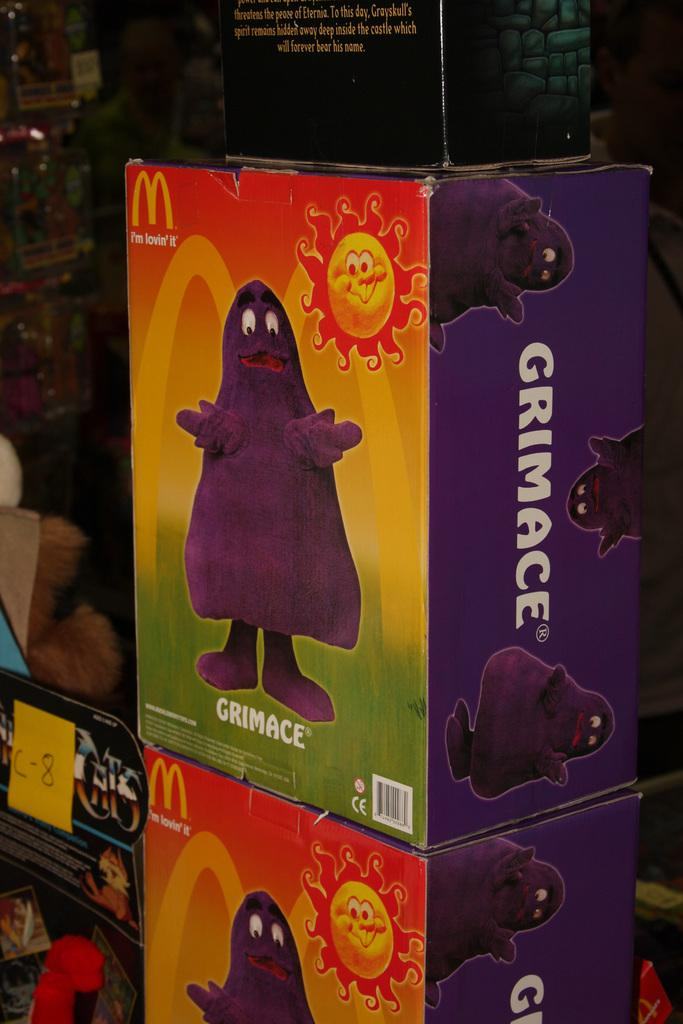Provide a one-sentence caption for the provided image. Boxes from McDonald's feature a drawing of a sunshine and Grimace under it. 